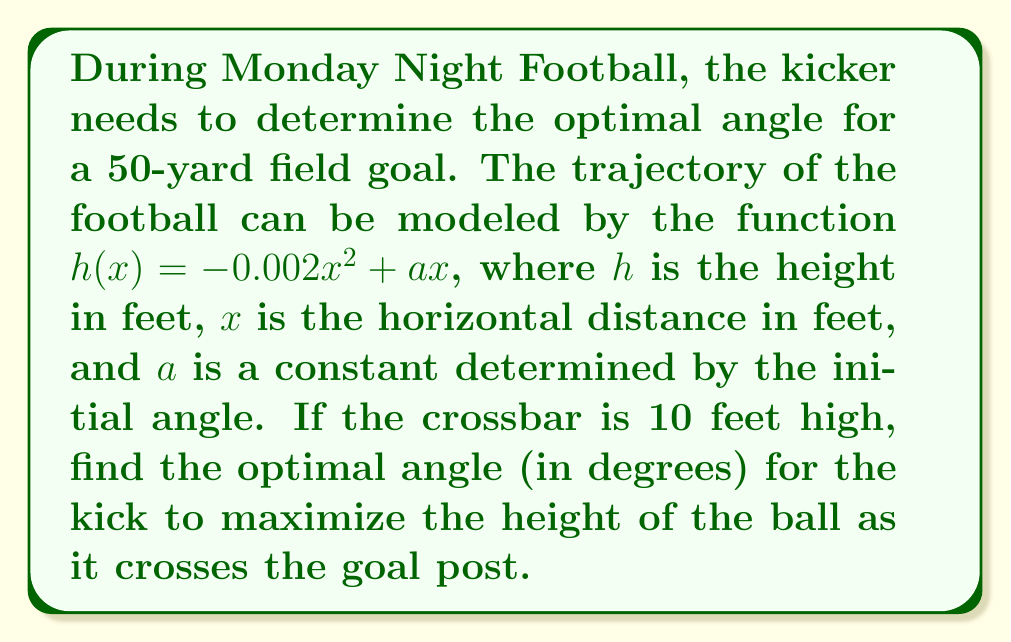Give your solution to this math problem. 1) First, we need to find the value of $a$ that maximizes the height at $x = 150$ feet (50 yards).

2) The height at the goal post is given by:
   $h(150) = -0.002(150)^2 + 150a = -45 + 150a$

3) To find the maximum height, we need to differentiate $h(x)$ with respect to $x$:
   $h'(x) = -0.004x + a$

4) Set $h'(x) = 0$ to find the maximum:
   $-0.004x + a = 0$
   $a = 0.004x$

5) At $x = 150$, $a = 0.004(150) = 0.6$

6) Now we can find the maximum height:
   $h(150) = -45 + 150(0.6) = 45$ feet

7) The initial angle $\theta$ can be found using:
   $\tan(\theta) = h'(0) = a = 0.6$

8) Therefore:
   $\theta = \arctan(0.6) \approx 30.96$ degrees
Answer: $30.96°$ 